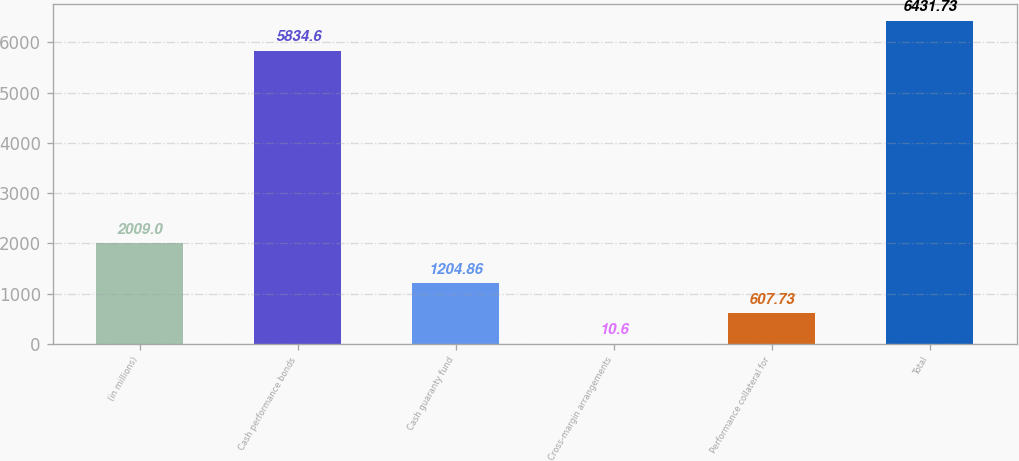Convert chart to OTSL. <chart><loc_0><loc_0><loc_500><loc_500><bar_chart><fcel>(in millions)<fcel>Cash performance bonds<fcel>Cash guaranty fund<fcel>Cross-margin arrangements<fcel>Performance collateral for<fcel>Total<nl><fcel>2009<fcel>5834.6<fcel>1204.86<fcel>10.6<fcel>607.73<fcel>6431.73<nl></chart> 